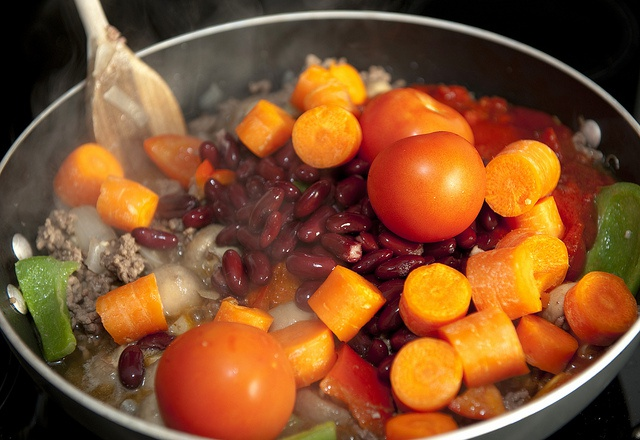Describe the objects in this image and their specific colors. I can see dining table in black, maroon, orange, red, and gray tones, bowl in black, maroon, orange, and red tones, carrot in black, red, brown, and orange tones, spoon in black, tan, and gray tones, and carrot in black, orange, red, gold, and brown tones in this image. 